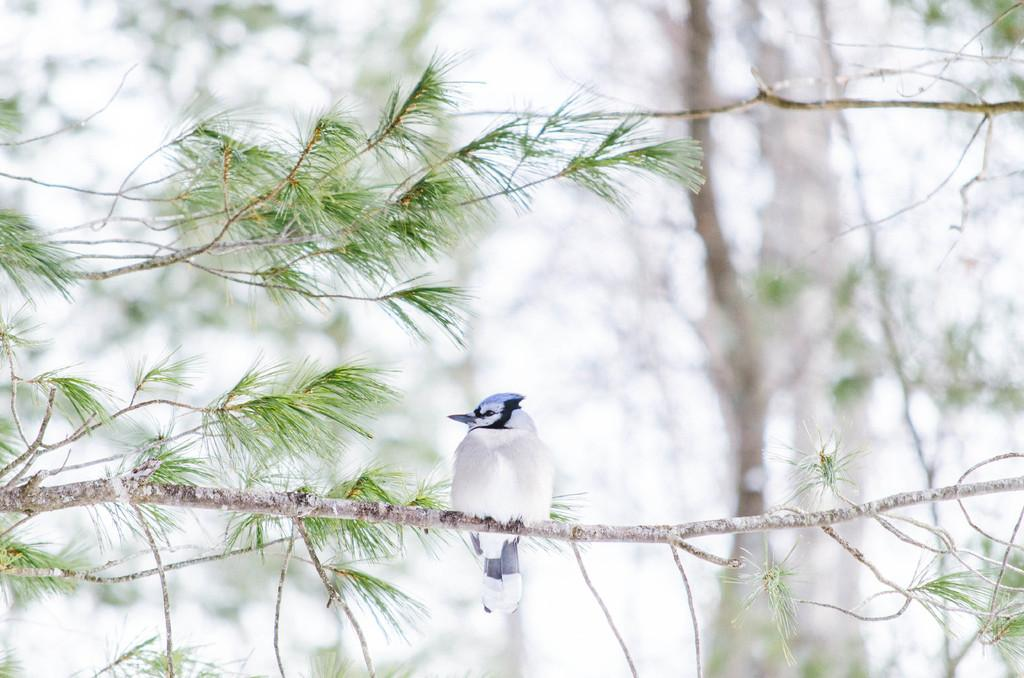What type of vegetation is present in the image? There are trees in the image. Can you describe the bird in the image? The bird is above the trees in the image. What songs are the snails singing in the image? There are no snails present in the image, so there is no singing or songs to be heard. 